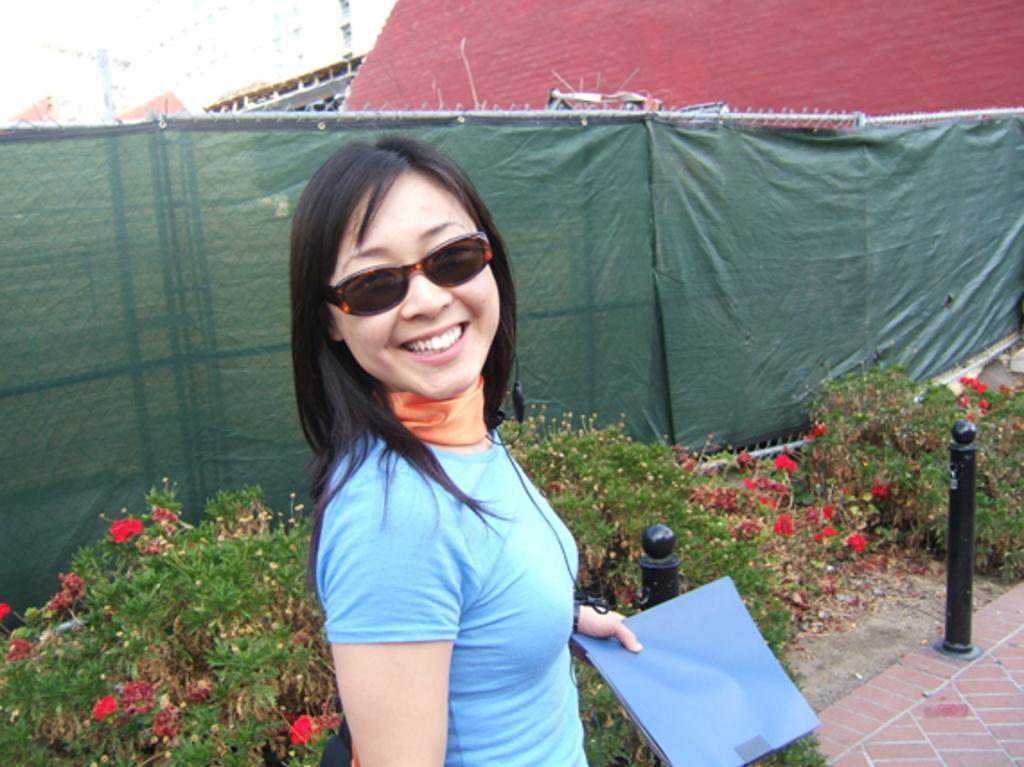Describe this image in one or two sentences. In this image, at the middle there is a woman, she is standing and she is smiling, she is holding a file, she is wearing specs, there are some green color plants, there is a green color cloth on the fence, at the background there is a red color wall. 